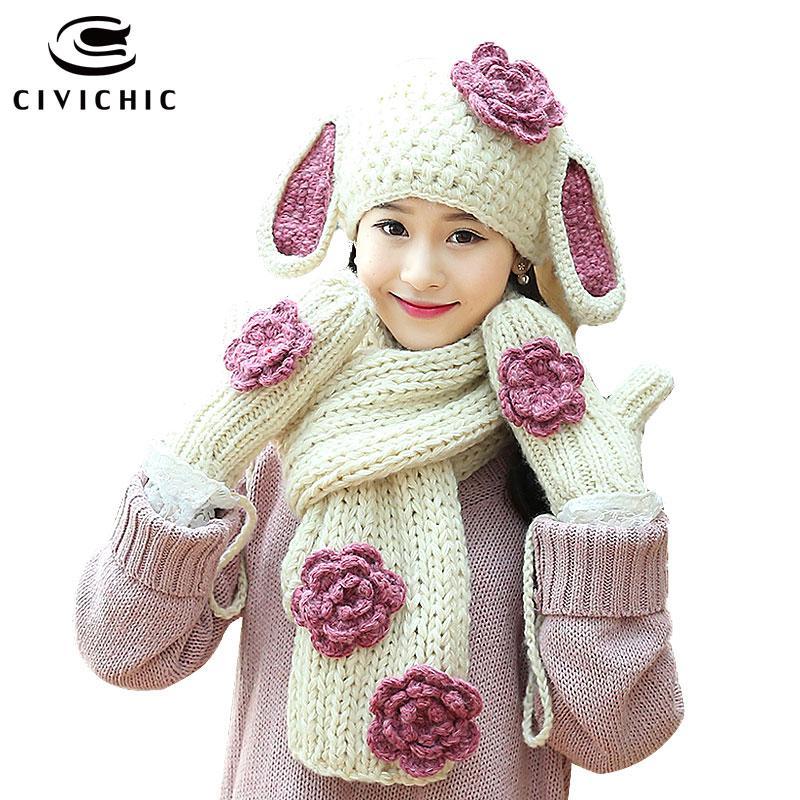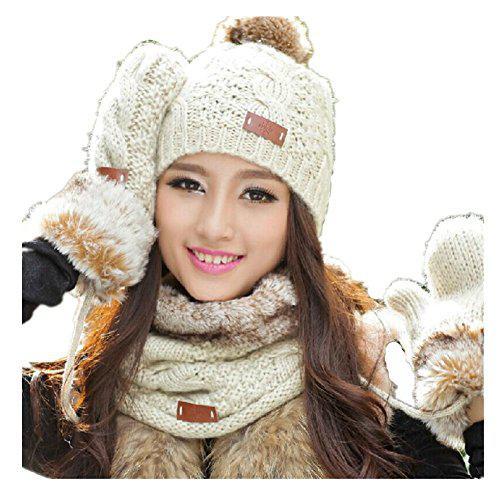The first image is the image on the left, the second image is the image on the right. Considering the images on both sides, is "The woman in the image on the left is wearing a hat and a scarf." valid? Answer yes or no. Yes. The first image is the image on the left, the second image is the image on the right. Evaluate the accuracy of this statement regarding the images: "The model in one image wears a hat with animal ears and coordinating mittens.". Is it true? Answer yes or no. Yes. 